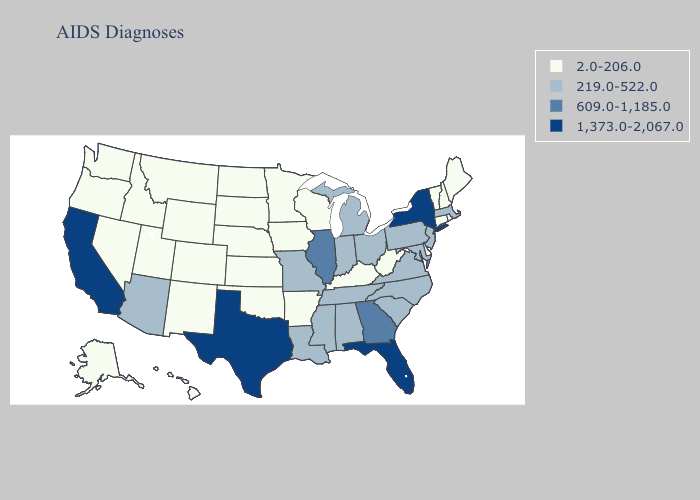Does Washington have the same value as Missouri?
Concise answer only. No. Does Massachusetts have the highest value in the Northeast?
Write a very short answer. No. What is the value of Tennessee?
Give a very brief answer. 219.0-522.0. What is the value of Missouri?
Short answer required. 219.0-522.0. Name the states that have a value in the range 1,373.0-2,067.0?
Answer briefly. California, Florida, New York, Texas. Does the map have missing data?
Short answer required. No. How many symbols are there in the legend?
Quick response, please. 4. Among the states that border Delaware , which have the highest value?
Short answer required. Maryland, New Jersey, Pennsylvania. Name the states that have a value in the range 2.0-206.0?
Concise answer only. Alaska, Arkansas, Colorado, Connecticut, Delaware, Hawaii, Idaho, Iowa, Kansas, Kentucky, Maine, Minnesota, Montana, Nebraska, Nevada, New Hampshire, New Mexico, North Dakota, Oklahoma, Oregon, Rhode Island, South Dakota, Utah, Vermont, Washington, West Virginia, Wisconsin, Wyoming. What is the highest value in the South ?
Quick response, please. 1,373.0-2,067.0. What is the lowest value in the South?
Write a very short answer. 2.0-206.0. What is the value of Kansas?
Keep it brief. 2.0-206.0. Among the states that border Colorado , which have the highest value?
Quick response, please. Arizona. Name the states that have a value in the range 2.0-206.0?
Write a very short answer. Alaska, Arkansas, Colorado, Connecticut, Delaware, Hawaii, Idaho, Iowa, Kansas, Kentucky, Maine, Minnesota, Montana, Nebraska, Nevada, New Hampshire, New Mexico, North Dakota, Oklahoma, Oregon, Rhode Island, South Dakota, Utah, Vermont, Washington, West Virginia, Wisconsin, Wyoming. What is the value of Colorado?
Concise answer only. 2.0-206.0. 